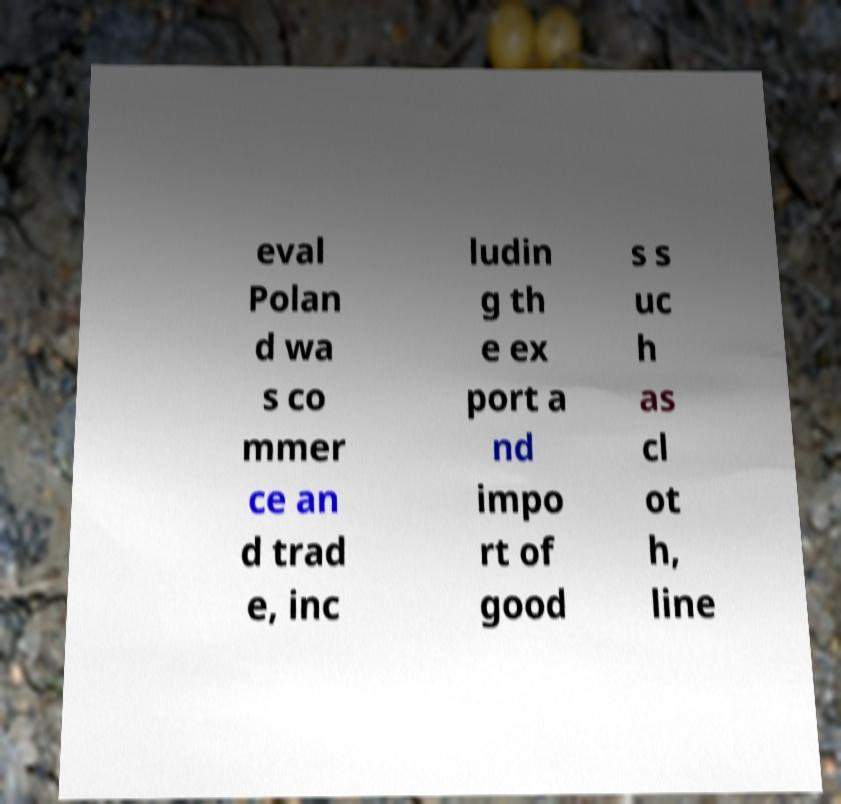Please read and relay the text visible in this image. What does it say? eval Polan d wa s co mmer ce an d trad e, inc ludin g th e ex port a nd impo rt of good s s uc h as cl ot h, line 